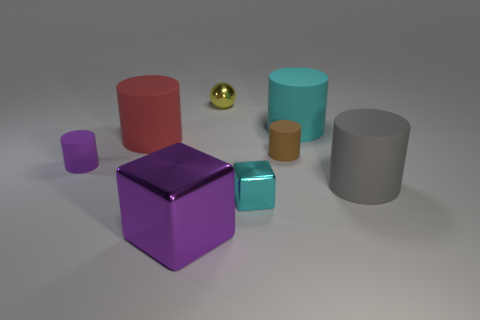Are there any other things that have the same shape as the yellow metal object?
Your answer should be very brief. No. Are there any tiny cyan things right of the metal object behind the big cylinder in front of the purple rubber cylinder?
Provide a succinct answer. Yes. There is a yellow ball that is behind the brown cylinder; what material is it?
Offer a terse response. Metal. Is the shape of the small yellow shiny object the same as the tiny object that is to the left of the yellow shiny sphere?
Your answer should be very brief. No. Are there an equal number of small metal blocks that are behind the tiny purple object and tiny cyan metallic cubes that are on the right side of the small cube?
Offer a very short reply. Yes. How many other things are there of the same material as the gray cylinder?
Your answer should be compact. 4. What number of rubber things are small purple objects or blocks?
Give a very brief answer. 1. There is a matte object behind the big red thing; is its shape the same as the gray matte thing?
Your answer should be compact. Yes. Are there more gray rubber cylinders in front of the purple matte cylinder than tiny cyan things?
Your answer should be compact. No. What number of large matte cylinders are both to the right of the big cyan object and left of the big block?
Offer a terse response. 0. 